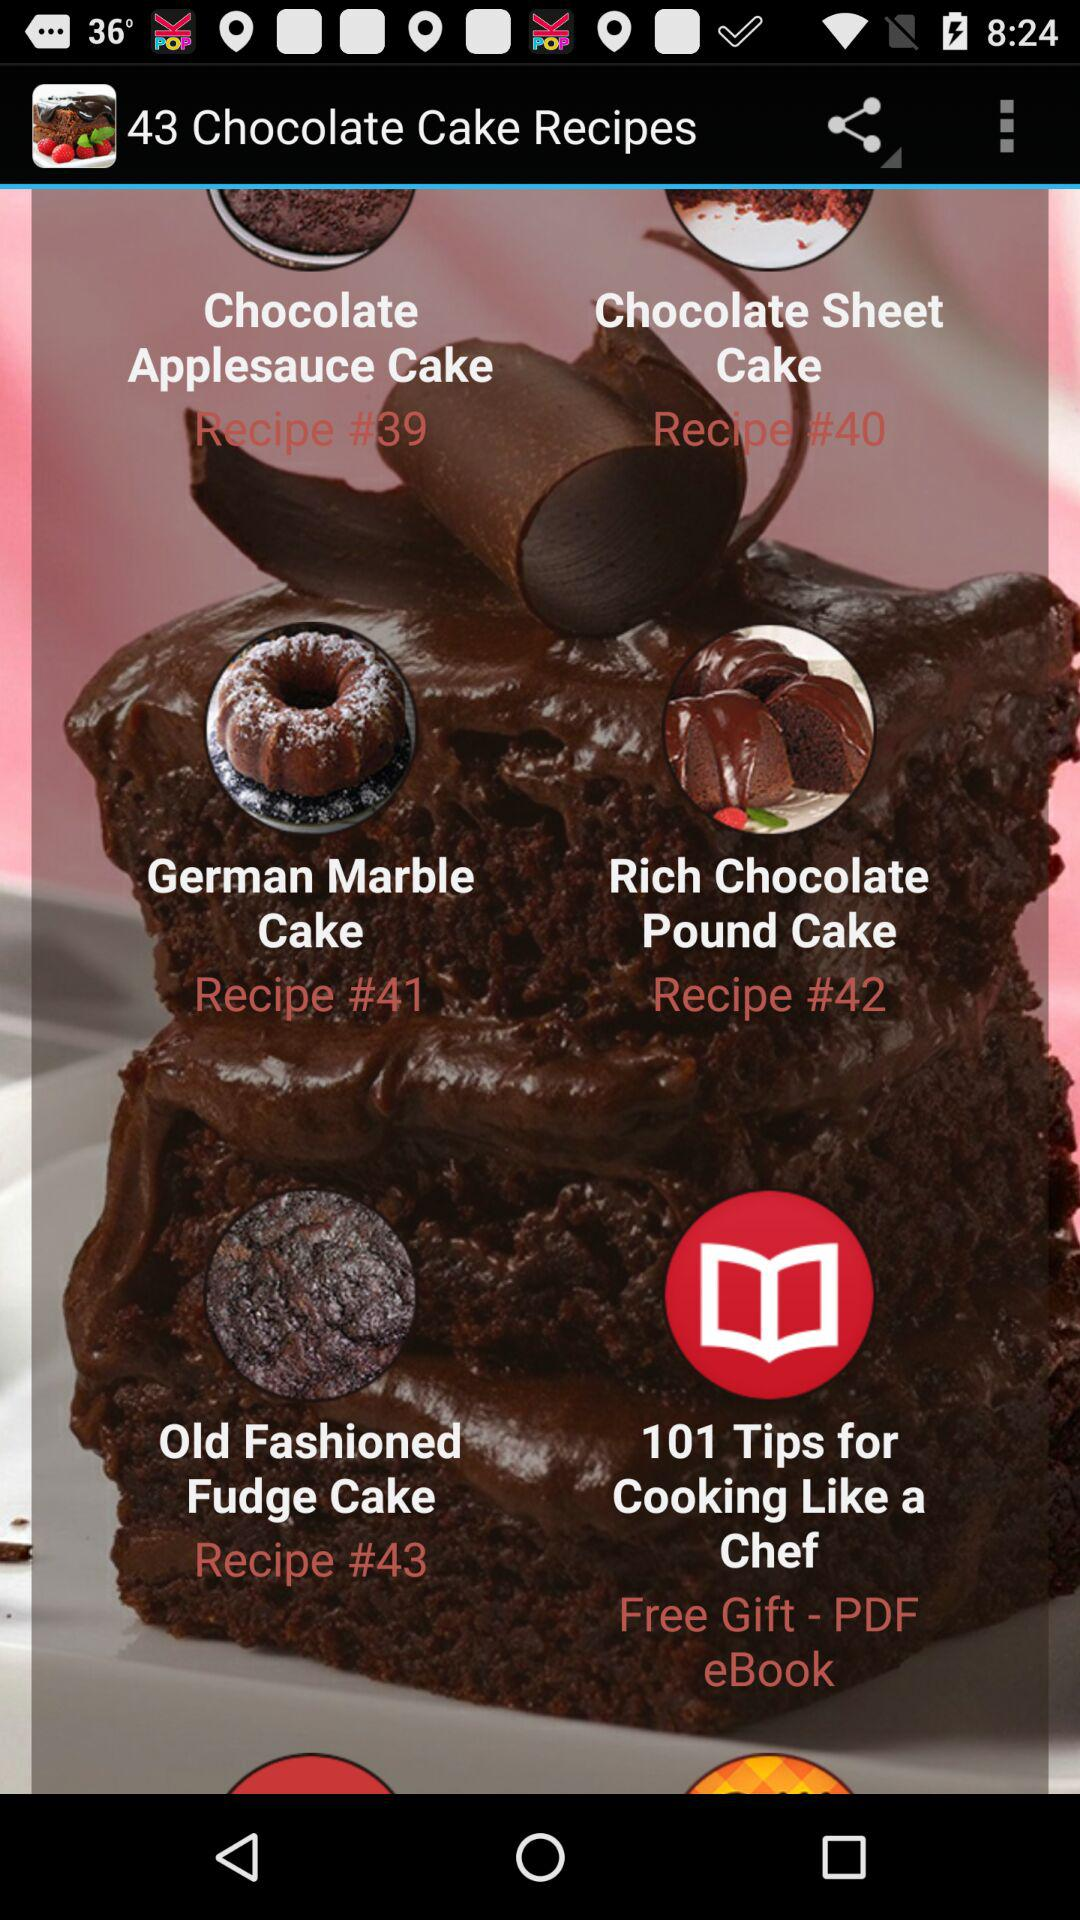What is the recipe number for the Chocolate Sheet Cake? The recipe number for the Chocolate Sheet Cake is 40. 